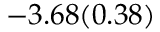<formula> <loc_0><loc_0><loc_500><loc_500>- 3 . 6 8 ( 0 . 3 8 )</formula> 